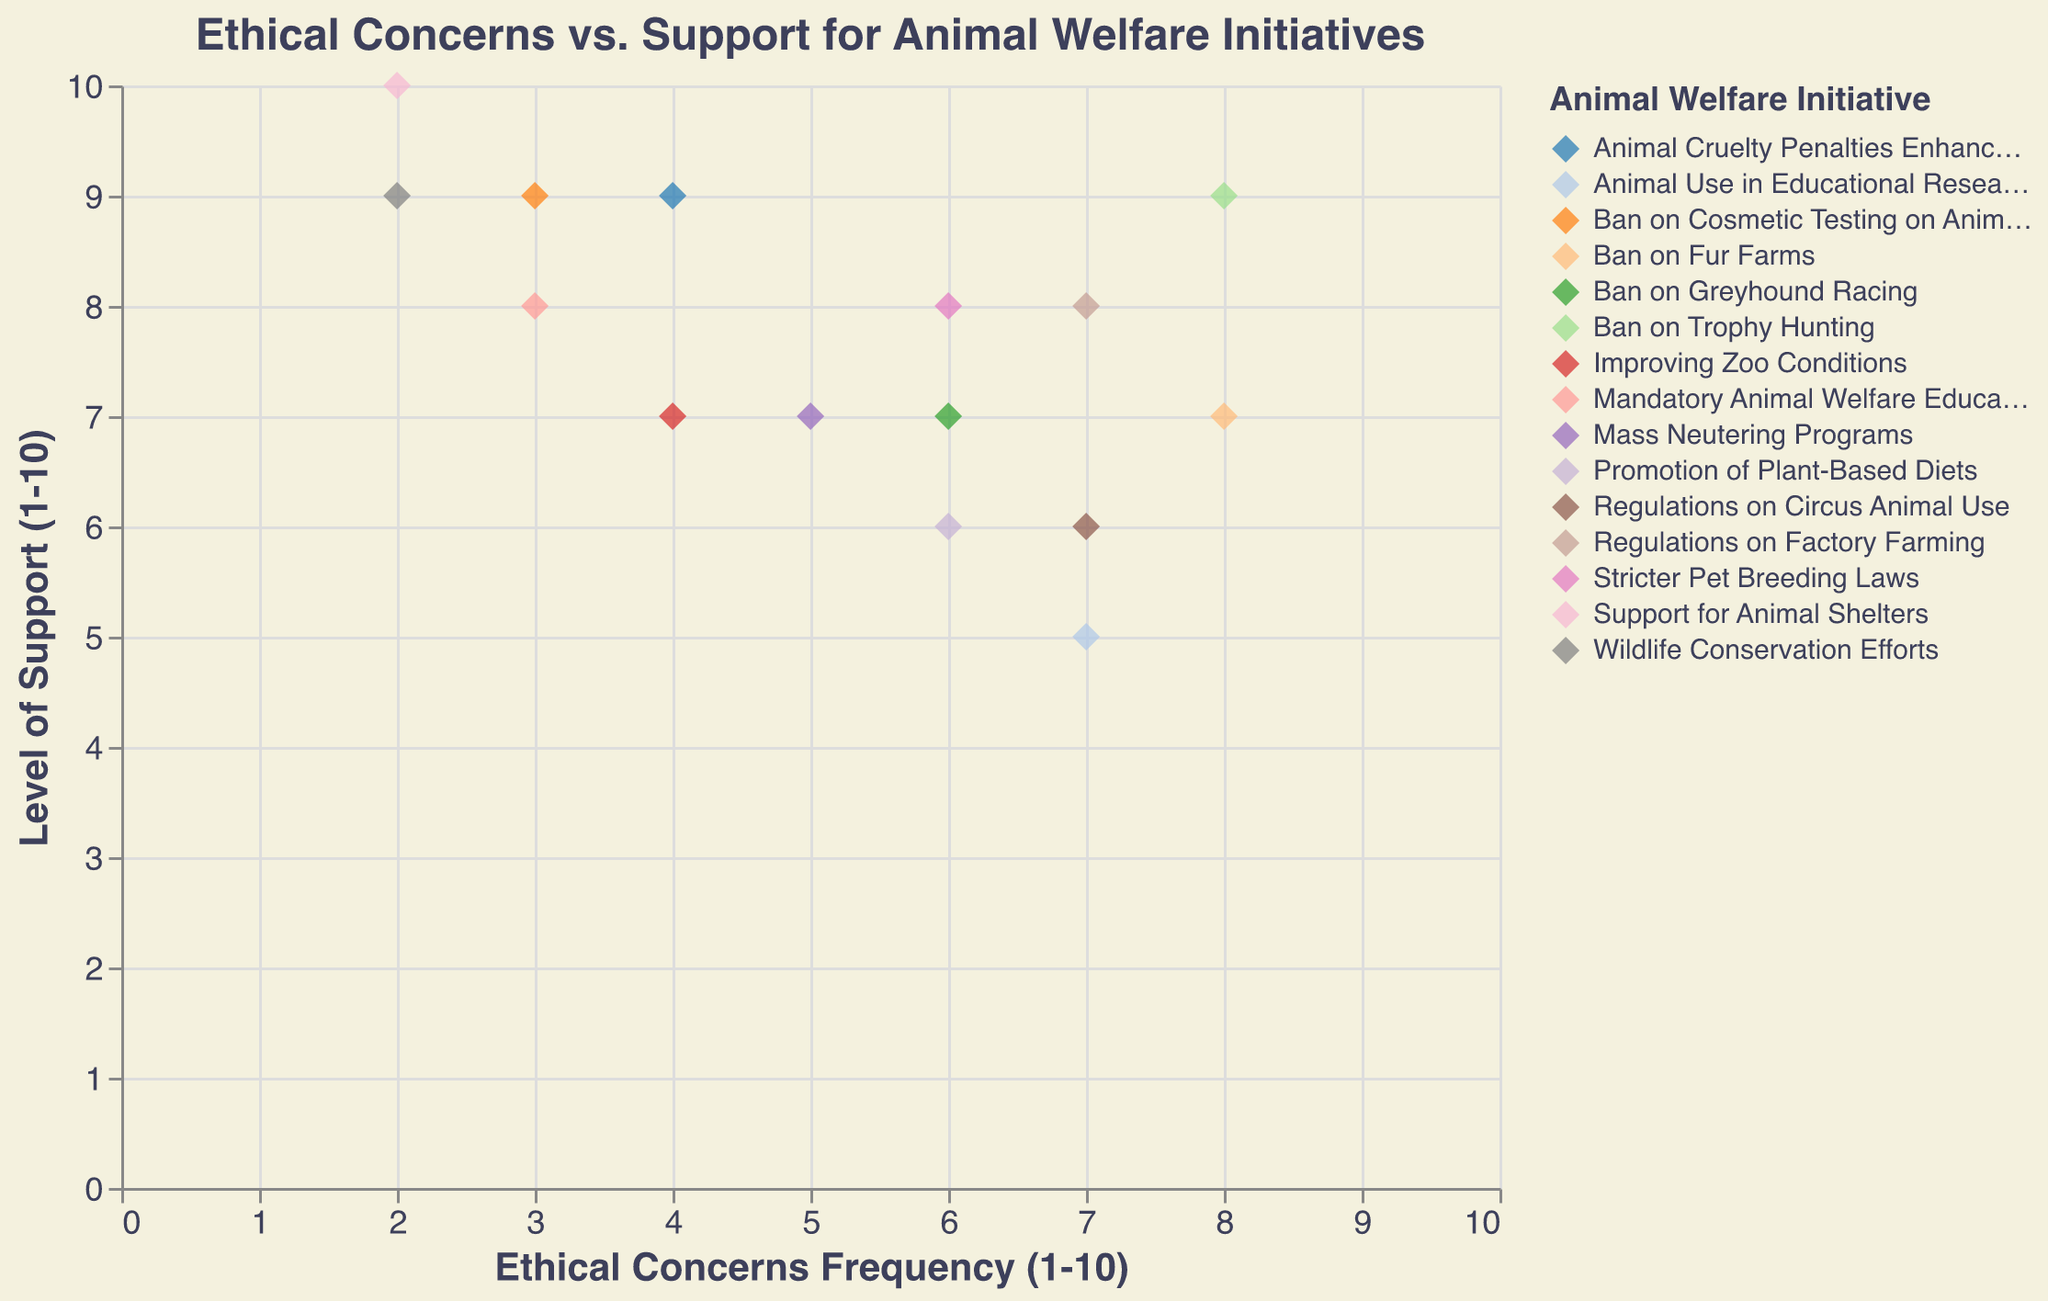What is the title of the scatter plot? The title of the scatter plot is usually placed at the top center of the chart. It describes the primary subject and relationships being plotted.
Answer: Ethical Concerns vs. Support for Animal Welfare Initiatives How many initiatives have an ethical concerns frequency of 6? Count the number of data points (diamonds) on the scatter plot along the x-axis at position 6.
Answer: 3 Which initiative has the highest level of support? Identify the data point with the highest position on the y-axis, then read the corresponding initiative from the tooltip or legend.
Answer: Support for Animal Shelters Which initiative has the lowest ethical concerns frequency? Identify the data point with the lowest position on the x-axis, then read the corresponding initiative from the tooltip or legend.
Answer: Support for Animal Shelters and Wildlife Conservation Efforts What is the average level of support for all initiatives? Add all the support levels together, then divide by the number of initiatives. (9 + 8 + 7 + 9 + 7 + 6 + 8 + 9 + 9 + 5 + 8 + 7 + 10 + 7 + 6) / 15 = 115 / 15
Answer: 7.67 Which two initiatives have the same level of support but different ethical concerns frequency? Identify data points with the same y-coordinate value but different x-coordinate values.
Answer: Regulations on Factory Farming & Stricter Pet Breeding Laws (both Support: 8) and Regulations on Circus Animal Use & Promotion of Plant-Based Diets (both Support: 6) What is the range of ethical concerns frequency in the scatter plot? Subtract the smallest ethical concerns frequency from the largest. (8 - 2)
Answer: 6 Which initiatives fall into the top-right quadrant, indicating high ethical concerns frequency and high support? Identify data points in the top-right quadrant of the scatter plot, having both x and y values high.
Answer: Ban on Trophy Hunting, Ban on Fur Farms, Regulations on Factory Farming Is there a positive correlation between ethical concerns frequency and level of support? Look at the general trend of the points on the scatter plot. If higher ethical concerns tend to line up with higher support levels or vice versa, there is a positive correlation.
Answer: Yes 